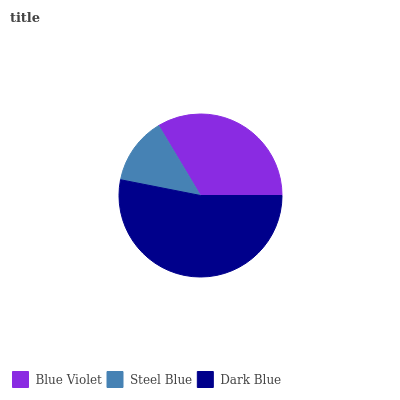Is Steel Blue the minimum?
Answer yes or no. Yes. Is Dark Blue the maximum?
Answer yes or no. Yes. Is Dark Blue the minimum?
Answer yes or no. No. Is Steel Blue the maximum?
Answer yes or no. No. Is Dark Blue greater than Steel Blue?
Answer yes or no. Yes. Is Steel Blue less than Dark Blue?
Answer yes or no. Yes. Is Steel Blue greater than Dark Blue?
Answer yes or no. No. Is Dark Blue less than Steel Blue?
Answer yes or no. No. Is Blue Violet the high median?
Answer yes or no. Yes. Is Blue Violet the low median?
Answer yes or no. Yes. Is Dark Blue the high median?
Answer yes or no. No. Is Steel Blue the low median?
Answer yes or no. No. 